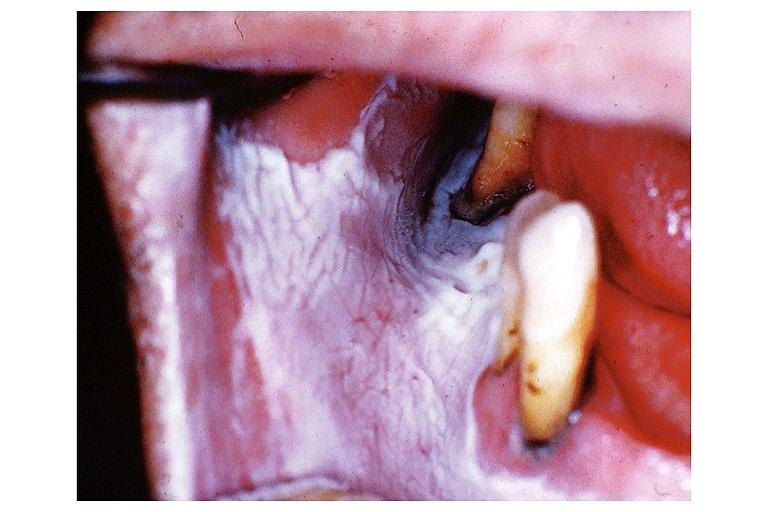what is present?
Answer the question using a single word or phrase. Oral 